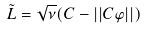<formula> <loc_0><loc_0><loc_500><loc_500>\tilde { L } = \sqrt { \nu } ( C - | | C \varphi | | )</formula> 